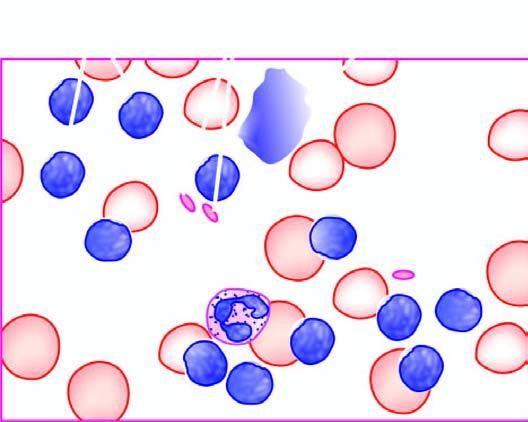what is there of mature and small differentiated lymphocytes?
Answer the question using a single word or phrase. Large excess 